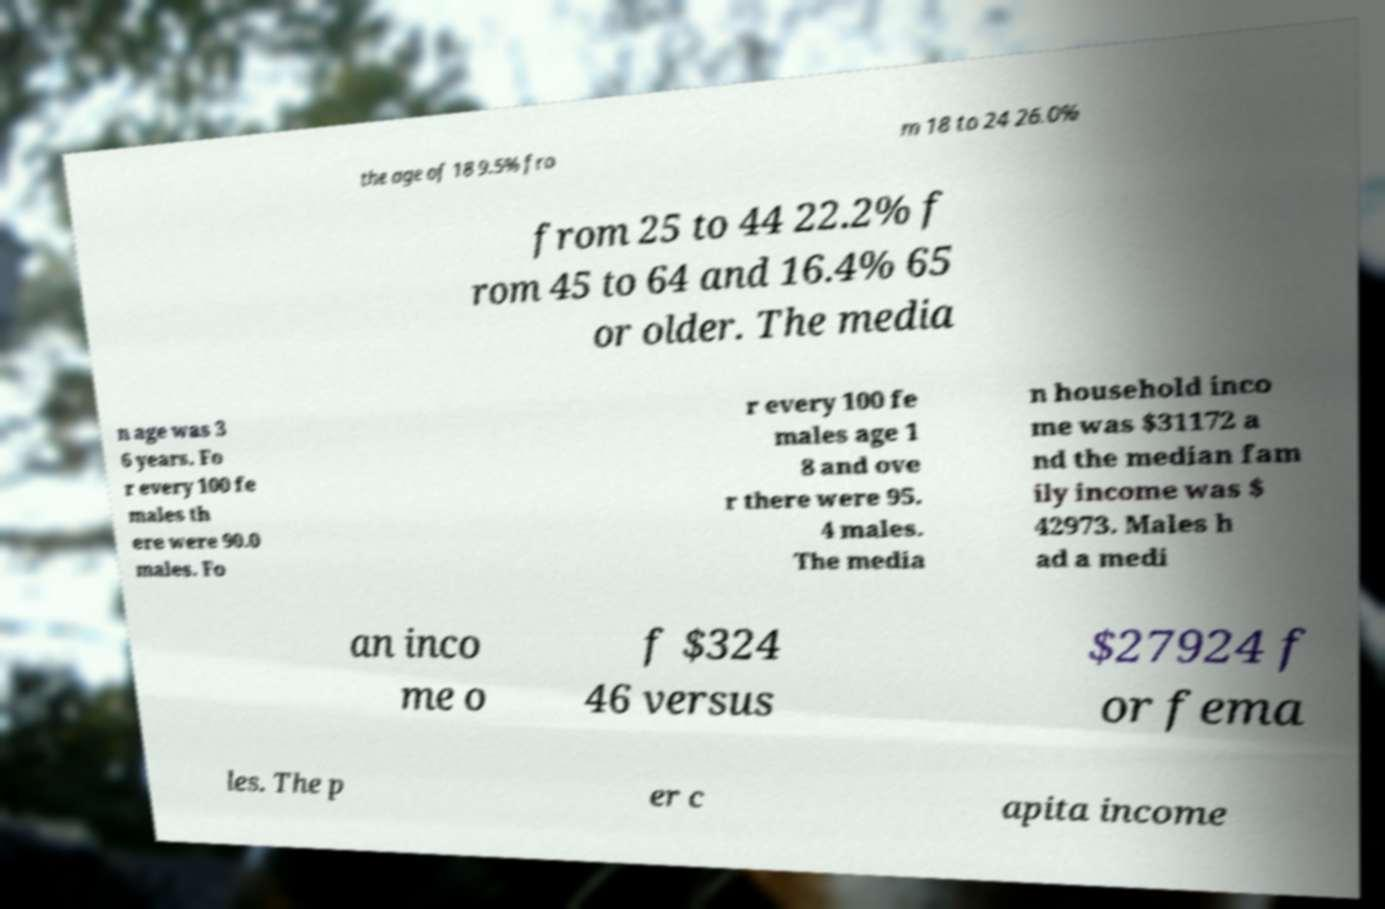Could you extract and type out the text from this image? the age of 18 9.5% fro m 18 to 24 26.0% from 25 to 44 22.2% f rom 45 to 64 and 16.4% 65 or older. The media n age was 3 6 years. Fo r every 100 fe males th ere were 90.0 males. Fo r every 100 fe males age 1 8 and ove r there were 95. 4 males. The media n household inco me was $31172 a nd the median fam ily income was $ 42973. Males h ad a medi an inco me o f $324 46 versus $27924 f or fema les. The p er c apita income 